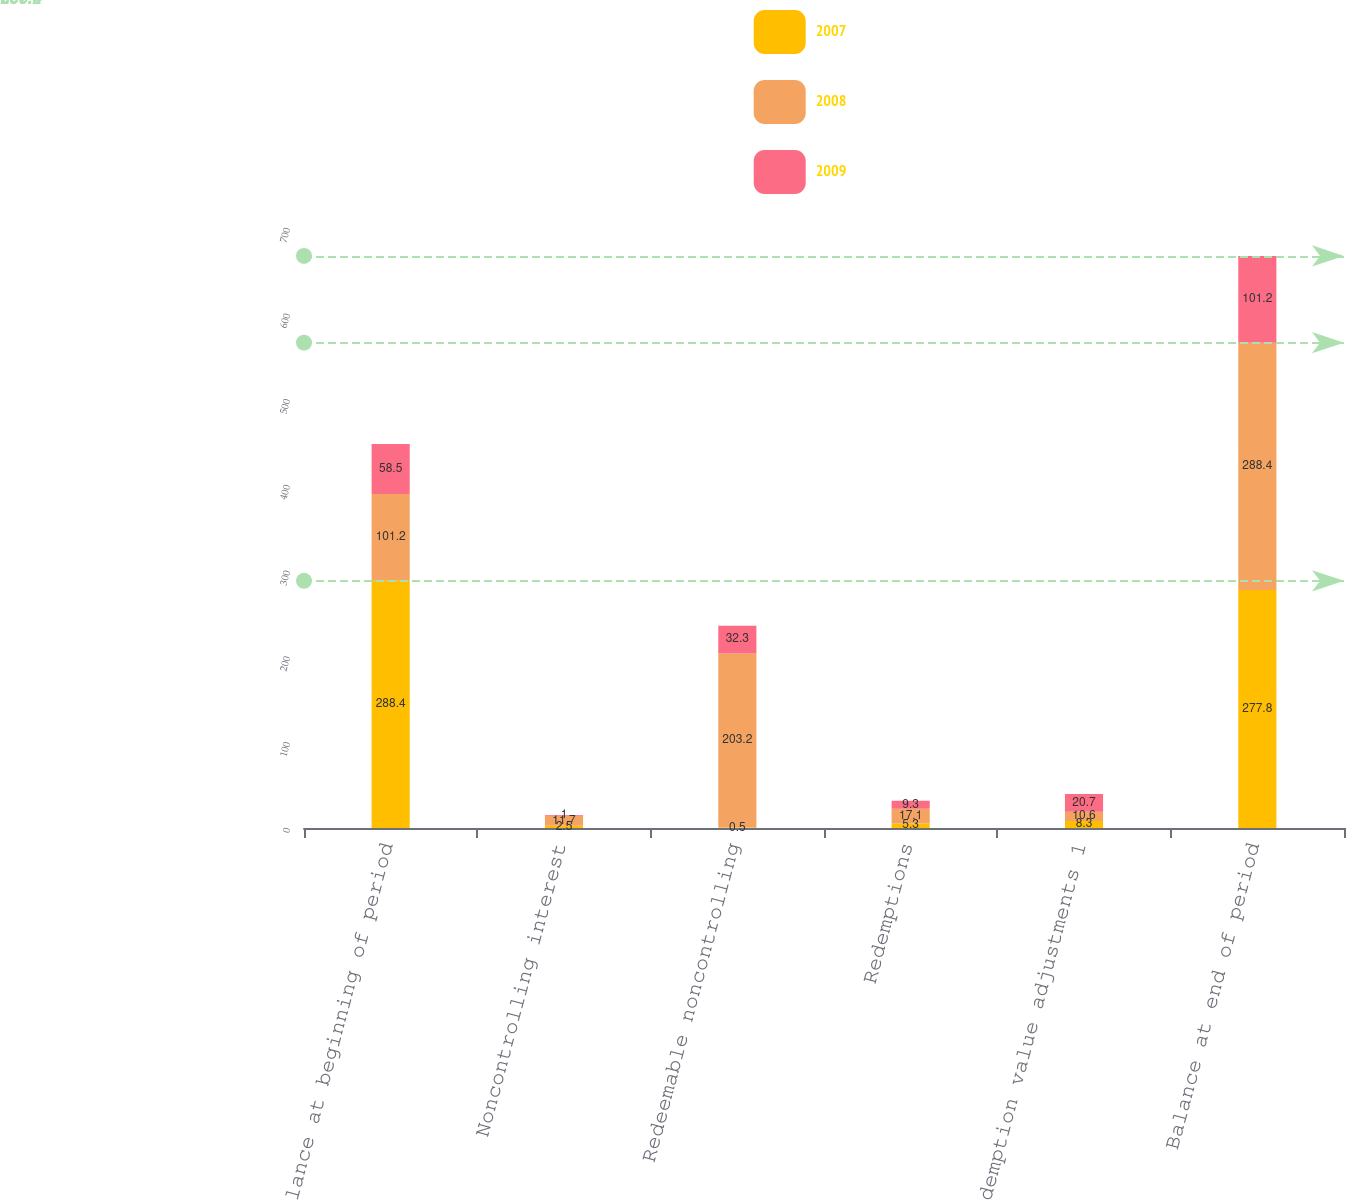Convert chart. <chart><loc_0><loc_0><loc_500><loc_500><stacked_bar_chart><ecel><fcel>Balance at beginning of period<fcel>Noncontrolling interest<fcel>Redeemable noncontrolling<fcel>Redemptions<fcel>Redemption value adjustments 1<fcel>Balance at end of period<nl><fcel>2007<fcel>288.4<fcel>2.5<fcel>0.5<fcel>5.3<fcel>8.3<fcel>277.8<nl><fcel>2008<fcel>101.2<fcel>11.7<fcel>203.2<fcel>17.1<fcel>10.6<fcel>288.4<nl><fcel>2009<fcel>58.5<fcel>1<fcel>32.3<fcel>9.3<fcel>20.7<fcel>101.2<nl></chart> 